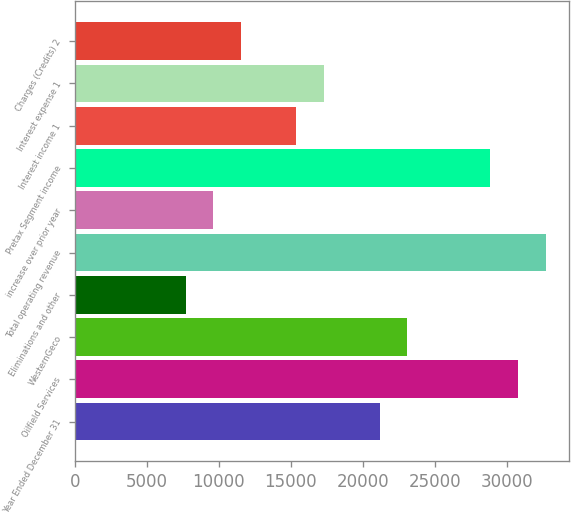Convert chart to OTSL. <chart><loc_0><loc_0><loc_500><loc_500><bar_chart><fcel>Year Ended December 31<fcel>Oilfield Services<fcel>WesternGeco<fcel>Eliminations and other<fcel>Total operating revenue<fcel>increase over prior year<fcel>Pretax Segment income<fcel>Interest income 1<fcel>Interest expense 1<fcel>Charges (Credits) 2<nl><fcel>21153<fcel>30767.7<fcel>23075.9<fcel>7692.3<fcel>32690.7<fcel>9615.25<fcel>28844.8<fcel>15384.1<fcel>17307<fcel>11538.2<nl></chart> 